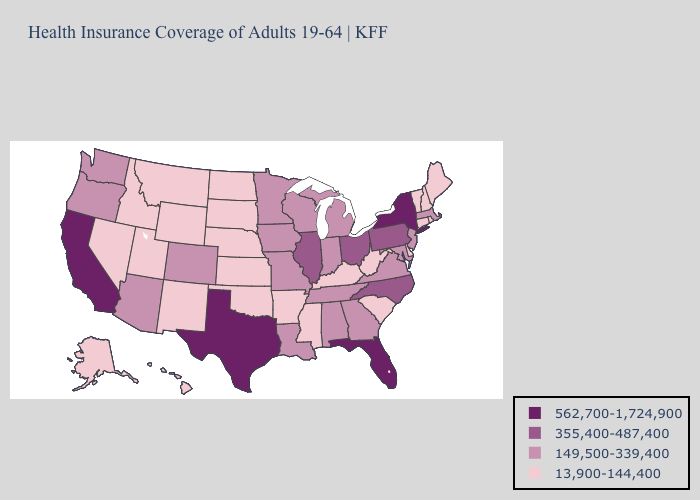What is the highest value in the South ?
Quick response, please. 562,700-1,724,900. Does Florida have the highest value in the USA?
Give a very brief answer. Yes. What is the highest value in the South ?
Quick response, please. 562,700-1,724,900. Does North Dakota have the same value as Maryland?
Keep it brief. No. Name the states that have a value in the range 355,400-487,400?
Keep it brief. Illinois, North Carolina, Ohio, Pennsylvania. Does Utah have a higher value than Alaska?
Be succinct. No. What is the lowest value in the USA?
Be succinct. 13,900-144,400. Does Massachusetts have a higher value than Iowa?
Be succinct. No. Among the states that border New Hampshire , which have the highest value?
Concise answer only. Massachusetts. What is the value of Michigan?
Keep it brief. 149,500-339,400. Among the states that border Alabama , does Mississippi have the lowest value?
Write a very short answer. Yes. How many symbols are there in the legend?
Give a very brief answer. 4. Does the map have missing data?
Short answer required. No. What is the lowest value in states that border Maryland?
Write a very short answer. 13,900-144,400. Does Arkansas have a lower value than Indiana?
Be succinct. Yes. 